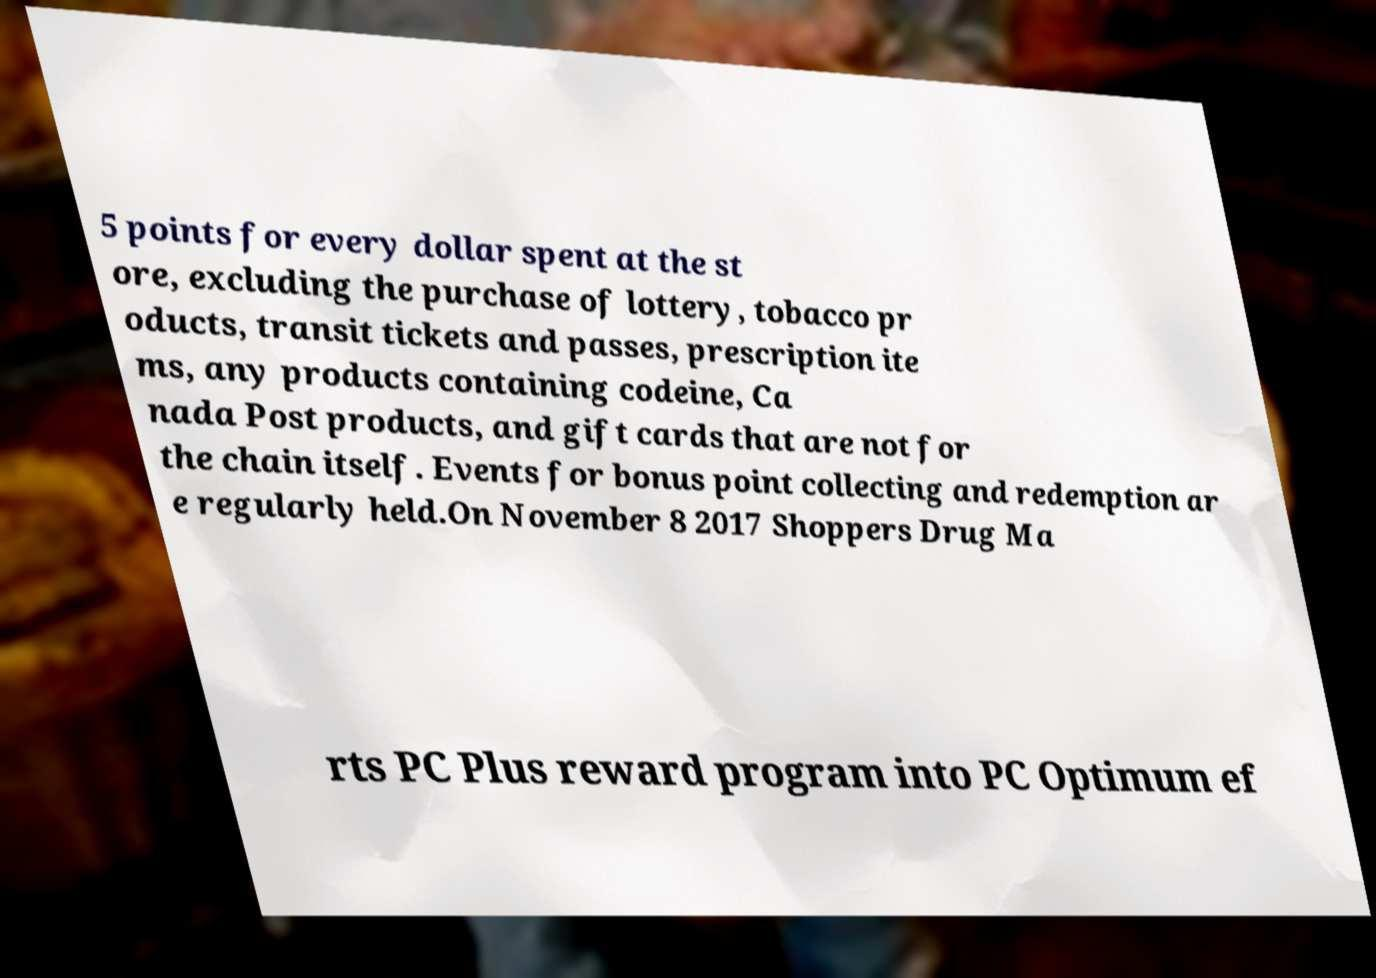I need the written content from this picture converted into text. Can you do that? 5 points for every dollar spent at the st ore, excluding the purchase of lottery, tobacco pr oducts, transit tickets and passes, prescription ite ms, any products containing codeine, Ca nada Post products, and gift cards that are not for the chain itself. Events for bonus point collecting and redemption ar e regularly held.On November 8 2017 Shoppers Drug Ma rts PC Plus reward program into PC Optimum ef 